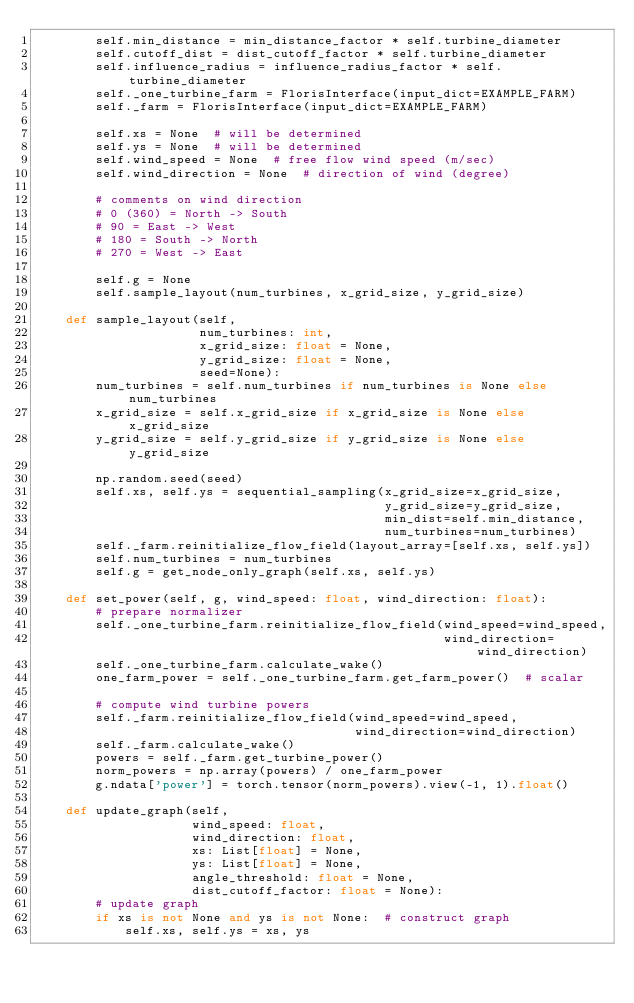<code> <loc_0><loc_0><loc_500><loc_500><_Python_>        self.min_distance = min_distance_factor * self.turbine_diameter
        self.cutoff_dist = dist_cutoff_factor * self.turbine_diameter
        self.influence_radius = influence_radius_factor * self.turbine_diameter
        self._one_turbine_farm = FlorisInterface(input_dict=EXAMPLE_FARM)
        self._farm = FlorisInterface(input_dict=EXAMPLE_FARM)

        self.xs = None  # will be determined
        self.ys = None  # will be determined
        self.wind_speed = None  # free flow wind speed (m/sec)
        self.wind_direction = None  # direction of wind (degree)

        # comments on wind direction
        # 0 (360) = North -> South
        # 90 = East -> West
        # 180 = South -> North
        # 270 = West -> East

        self.g = None
        self.sample_layout(num_turbines, x_grid_size, y_grid_size)

    def sample_layout(self,
                      num_turbines: int,
                      x_grid_size: float = None,
                      y_grid_size: float = None,
                      seed=None):
        num_turbines = self.num_turbines if num_turbines is None else num_turbines
        x_grid_size = self.x_grid_size if x_grid_size is None else x_grid_size
        y_grid_size = self.y_grid_size if y_grid_size is None else y_grid_size

        np.random.seed(seed)
        self.xs, self.ys = sequential_sampling(x_grid_size=x_grid_size,
                                               y_grid_size=y_grid_size,
                                               min_dist=self.min_distance,
                                               num_turbines=num_turbines)
        self._farm.reinitialize_flow_field(layout_array=[self.xs, self.ys])
        self.num_turbines = num_turbines
        self.g = get_node_only_graph(self.xs, self.ys)

    def set_power(self, g, wind_speed: float, wind_direction: float):
        # prepare normalizer
        self._one_turbine_farm.reinitialize_flow_field(wind_speed=wind_speed,
                                                       wind_direction=wind_direction)
        self._one_turbine_farm.calculate_wake()
        one_farm_power = self._one_turbine_farm.get_farm_power()  # scalar

        # compute wind turbine powers
        self._farm.reinitialize_flow_field(wind_speed=wind_speed,
                                           wind_direction=wind_direction)
        self._farm.calculate_wake()
        powers = self._farm.get_turbine_power()
        norm_powers = np.array(powers) / one_farm_power
        g.ndata['power'] = torch.tensor(norm_powers).view(-1, 1).float()

    def update_graph(self,
                     wind_speed: float,
                     wind_direction: float,
                     xs: List[float] = None,
                     ys: List[float] = None,
                     angle_threshold: float = None,
                     dist_cutoff_factor: float = None):
        # update graph
        if xs is not None and ys is not None:  # construct graph
            self.xs, self.ys = xs, ys        </code> 